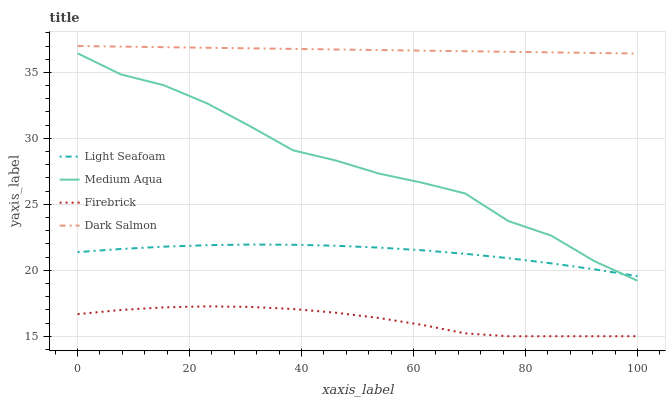Does Light Seafoam have the minimum area under the curve?
Answer yes or no. No. Does Light Seafoam have the maximum area under the curve?
Answer yes or no. No. Is Light Seafoam the smoothest?
Answer yes or no. No. Is Light Seafoam the roughest?
Answer yes or no. No. Does Light Seafoam have the lowest value?
Answer yes or no. No. Does Light Seafoam have the highest value?
Answer yes or no. No. Is Firebrick less than Light Seafoam?
Answer yes or no. Yes. Is Dark Salmon greater than Medium Aqua?
Answer yes or no. Yes. Does Firebrick intersect Light Seafoam?
Answer yes or no. No. 